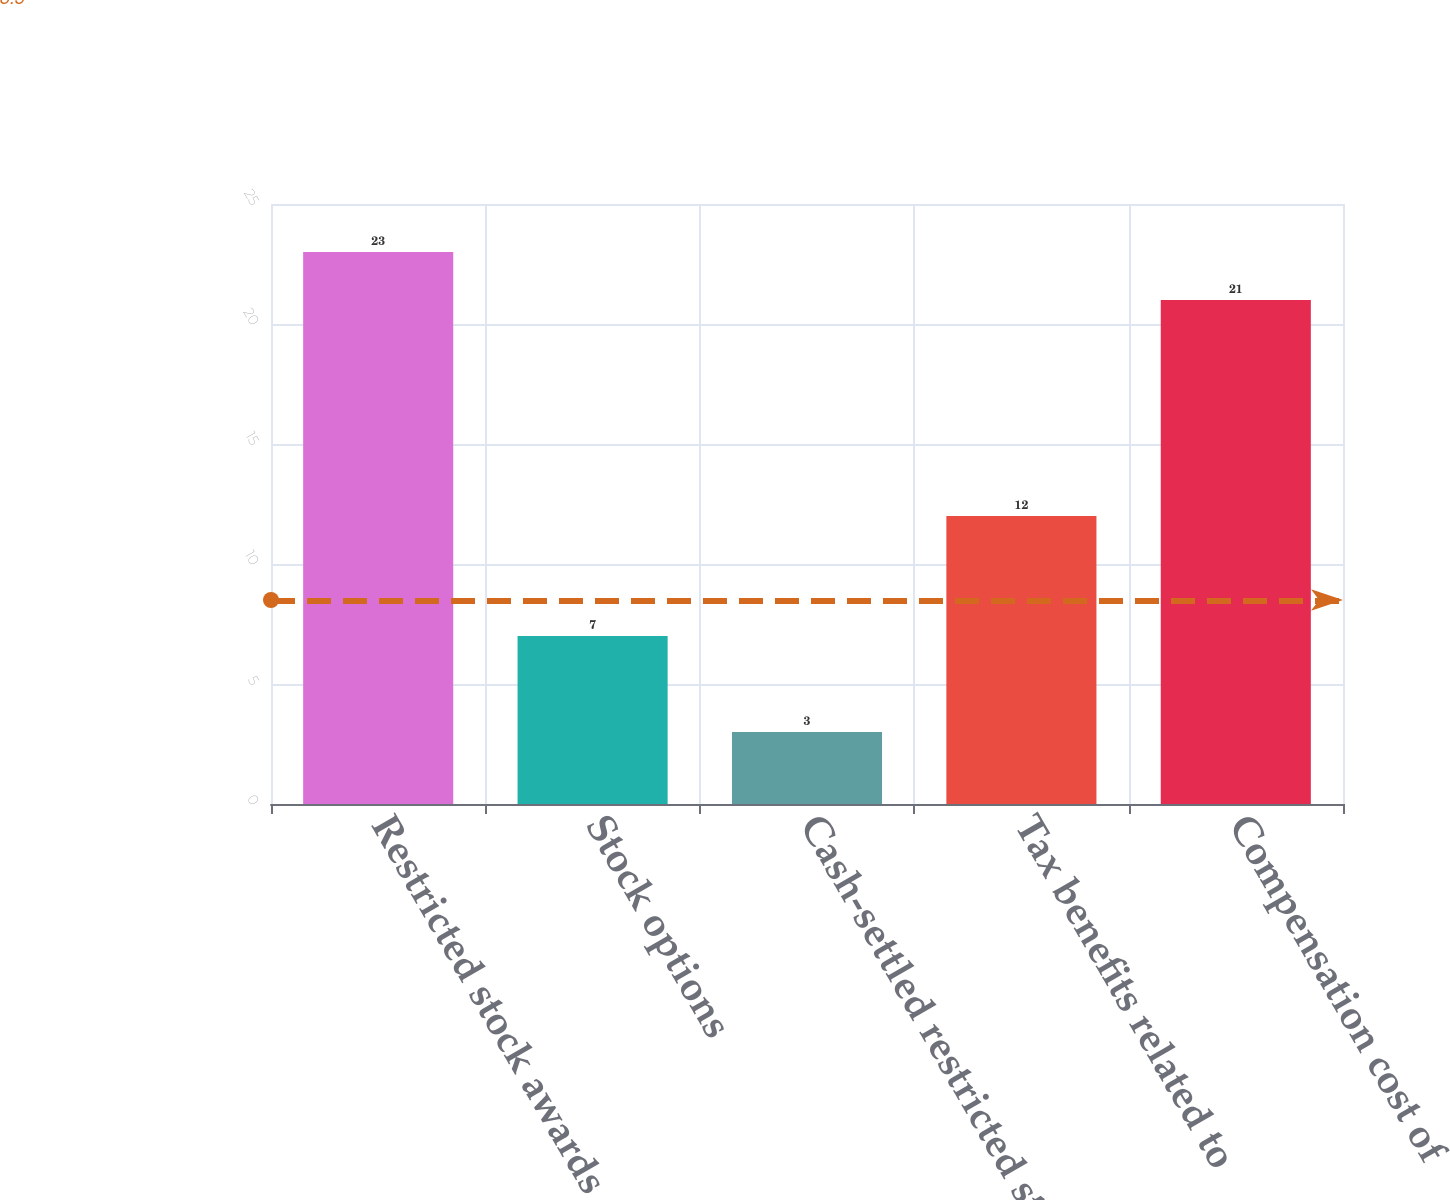Convert chart. <chart><loc_0><loc_0><loc_500><loc_500><bar_chart><fcel>Restricted stock awards<fcel>Stock options<fcel>Cash-settled restricted stock<fcel>Tax benefits related to<fcel>Compensation cost of<nl><fcel>23<fcel>7<fcel>3<fcel>12<fcel>21<nl></chart> 